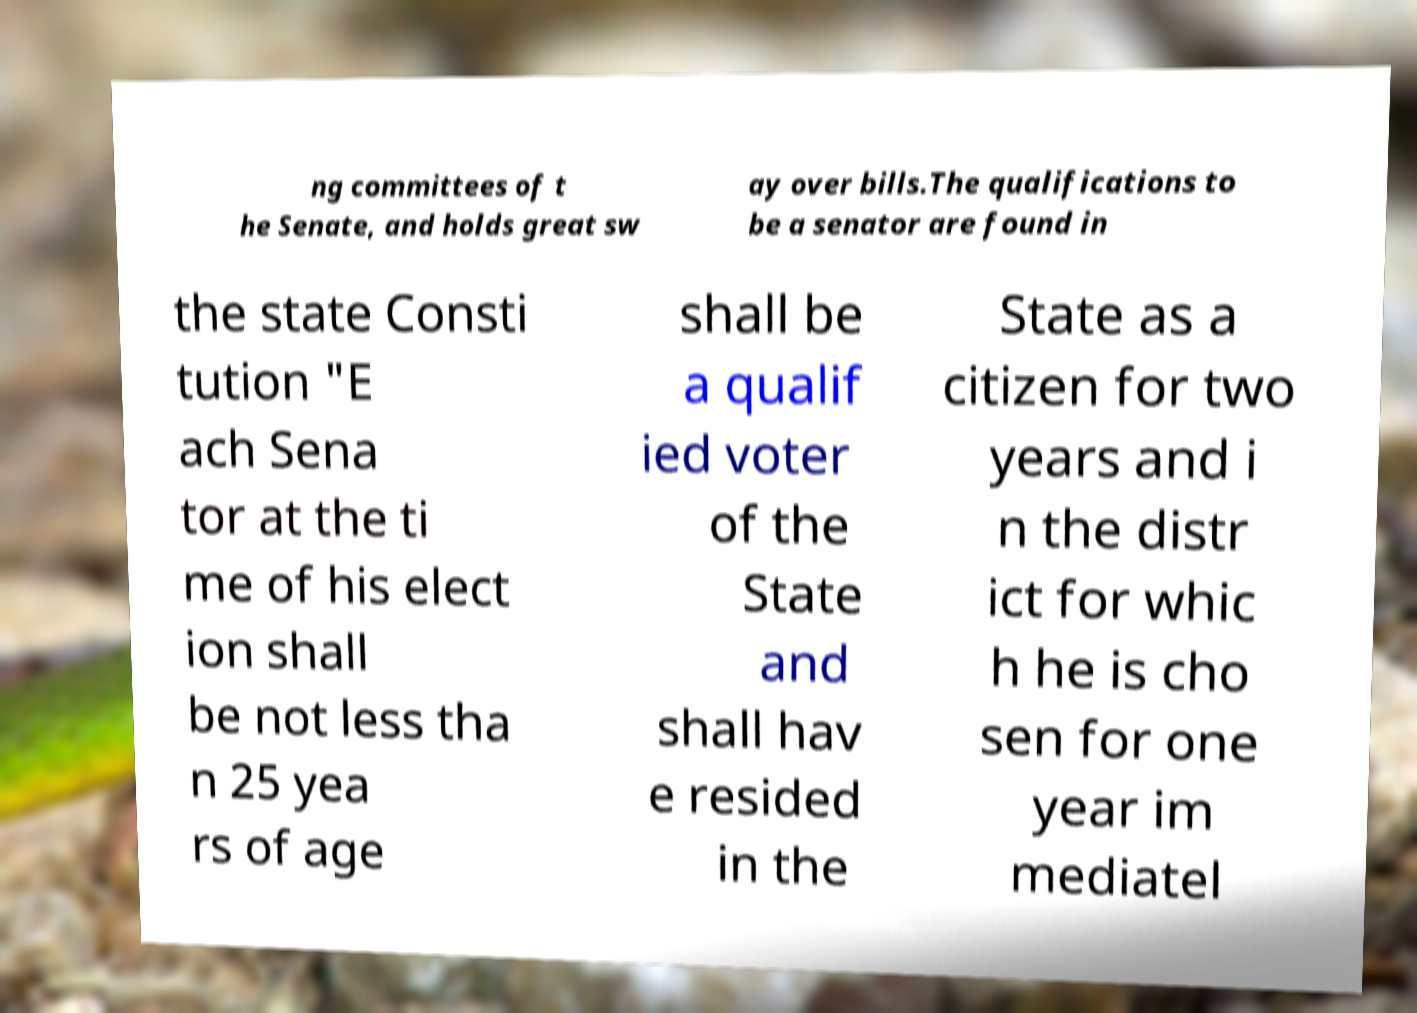For documentation purposes, I need the text within this image transcribed. Could you provide that? ng committees of t he Senate, and holds great sw ay over bills.The qualifications to be a senator are found in the state Consti tution "E ach Sena tor at the ti me of his elect ion shall be not less tha n 25 yea rs of age shall be a qualif ied voter of the State and shall hav e resided in the State as a citizen for two years and i n the distr ict for whic h he is cho sen for one year im mediatel 